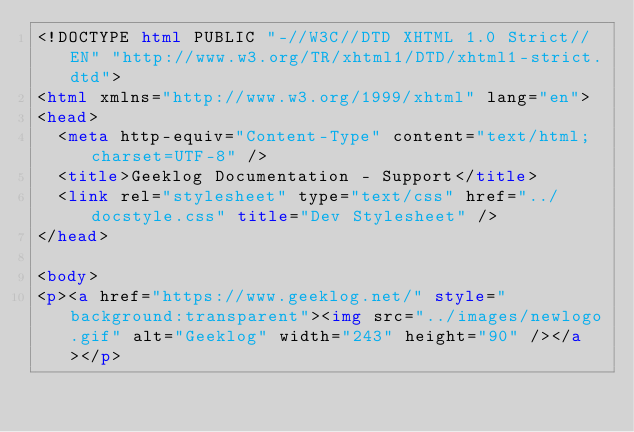<code> <loc_0><loc_0><loc_500><loc_500><_HTML_><!DOCTYPE html PUBLIC "-//W3C//DTD XHTML 1.0 Strict//EN" "http://www.w3.org/TR/xhtml1/DTD/xhtml1-strict.dtd">
<html xmlns="http://www.w3.org/1999/xhtml" lang="en">
<head>
  <meta http-equiv="Content-Type" content="text/html; charset=UTF-8" />
  <title>Geeklog Documentation - Support</title>
  <link rel="stylesheet" type="text/css" href="../docstyle.css" title="Dev Stylesheet" />
</head>

<body>
<p><a href="https://www.geeklog.net/" style="background:transparent"><img src="../images/newlogo.gif" alt="Geeklog" width="243" height="90" /></a></p></code> 